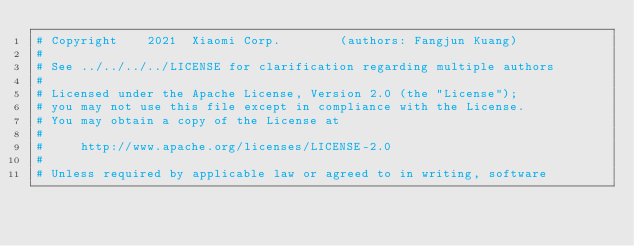<code> <loc_0><loc_0><loc_500><loc_500><_Python_># Copyright    2021  Xiaomi Corp.        (authors: Fangjun Kuang)
#
# See ../../../../LICENSE for clarification regarding multiple authors
#
# Licensed under the Apache License, Version 2.0 (the "License");
# you may not use this file except in compliance with the License.
# You may obtain a copy of the License at
#
#     http://www.apache.org/licenses/LICENSE-2.0
#
# Unless required by applicable law or agreed to in writing, software</code> 